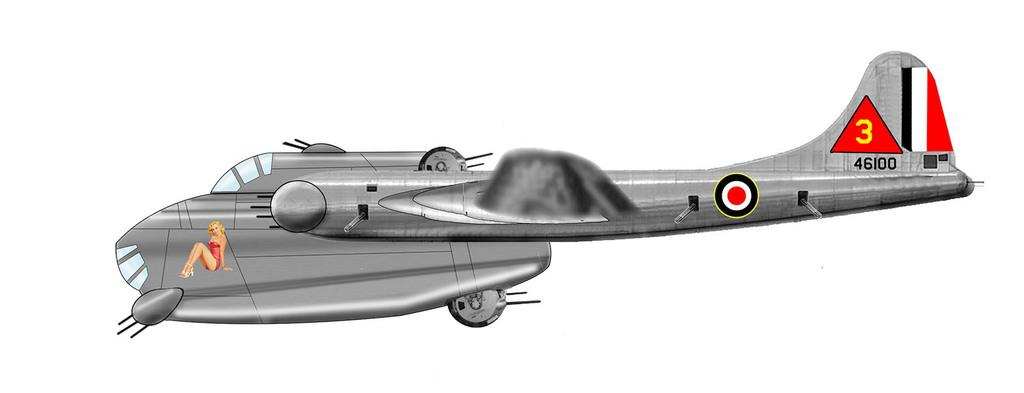<image>
Create a compact narrative representing the image presented. The number three is in a triangle on the tail of a plane. 